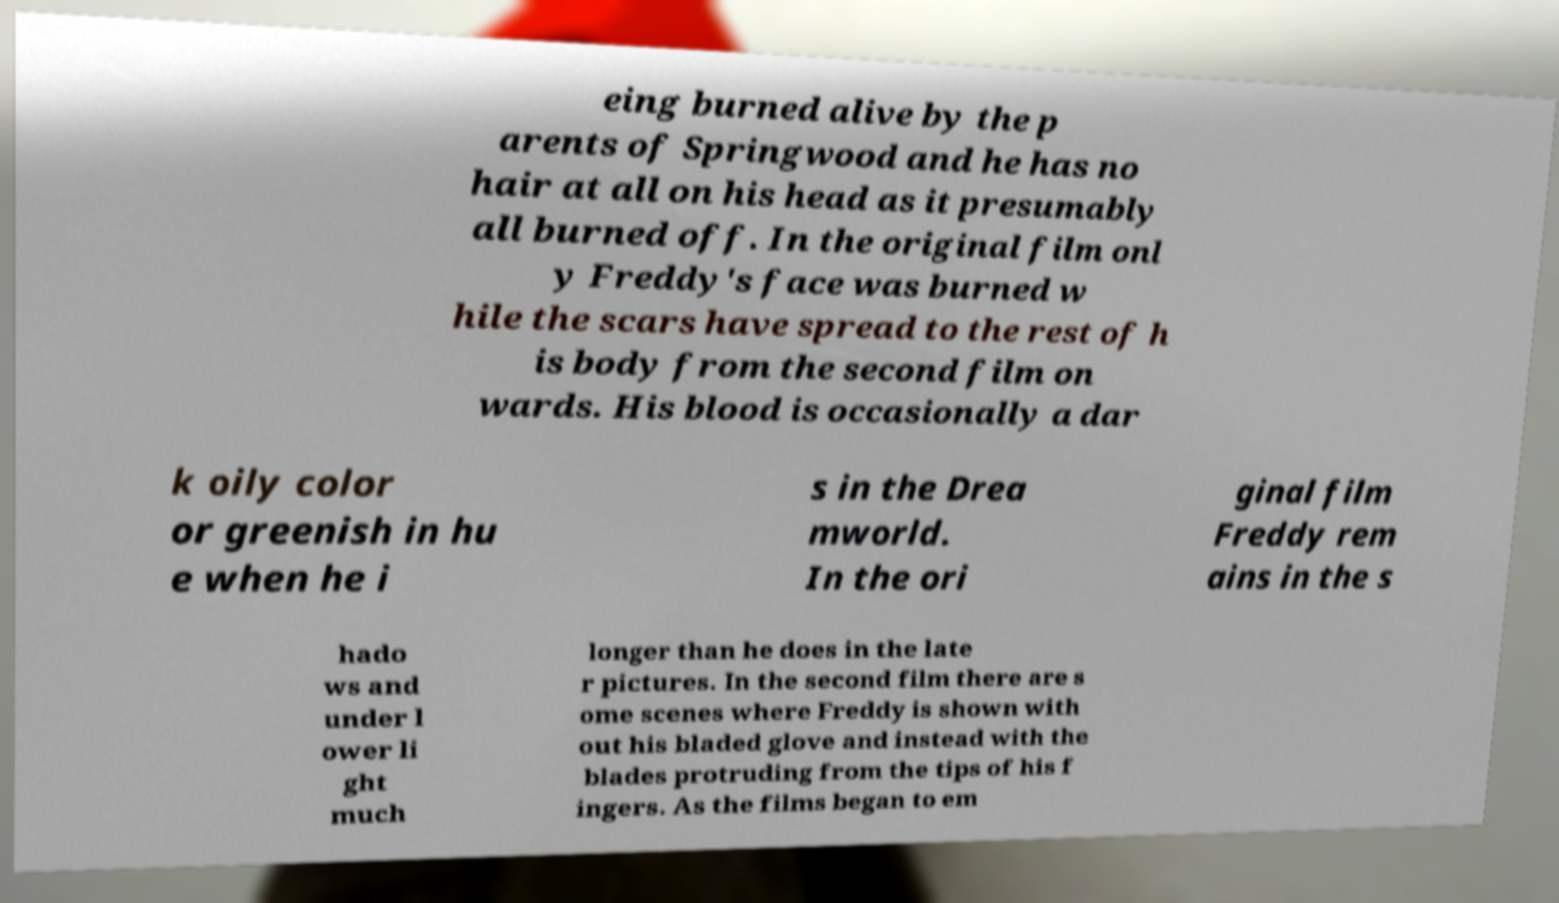Can you read and provide the text displayed in the image?This photo seems to have some interesting text. Can you extract and type it out for me? eing burned alive by the p arents of Springwood and he has no hair at all on his head as it presumably all burned off. In the original film onl y Freddy's face was burned w hile the scars have spread to the rest of h is body from the second film on wards. His blood is occasionally a dar k oily color or greenish in hu e when he i s in the Drea mworld. In the ori ginal film Freddy rem ains in the s hado ws and under l ower li ght much longer than he does in the late r pictures. In the second film there are s ome scenes where Freddy is shown with out his bladed glove and instead with the blades protruding from the tips of his f ingers. As the films began to em 